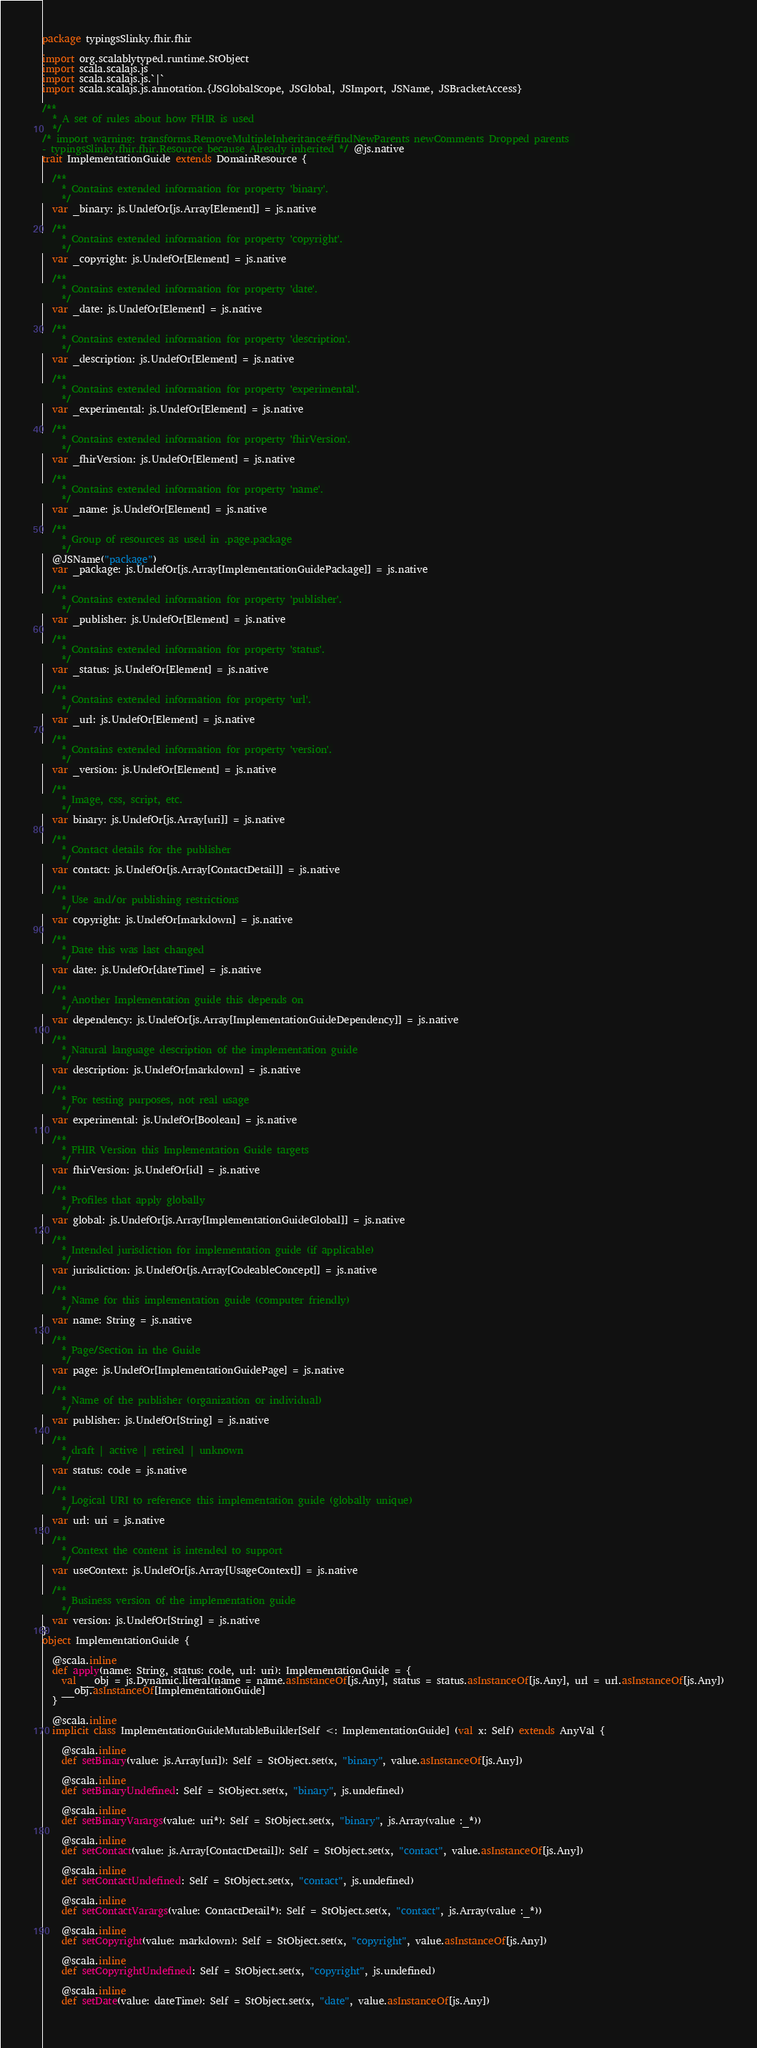<code> <loc_0><loc_0><loc_500><loc_500><_Scala_>package typingsSlinky.fhir.fhir

import org.scalablytyped.runtime.StObject
import scala.scalajs.js
import scala.scalajs.js.`|`
import scala.scalajs.js.annotation.{JSGlobalScope, JSGlobal, JSImport, JSName, JSBracketAccess}

/**
  * A set of rules about how FHIR is used
  */
/* import warning: transforms.RemoveMultipleInheritance#findNewParents newComments Dropped parents 
- typingsSlinky.fhir.fhir.Resource because Already inherited */ @js.native
trait ImplementationGuide extends DomainResource {
  
  /**
    * Contains extended information for property 'binary'.
    */
  var _binary: js.UndefOr[js.Array[Element]] = js.native
  
  /**
    * Contains extended information for property 'copyright'.
    */
  var _copyright: js.UndefOr[Element] = js.native
  
  /**
    * Contains extended information for property 'date'.
    */
  var _date: js.UndefOr[Element] = js.native
  
  /**
    * Contains extended information for property 'description'.
    */
  var _description: js.UndefOr[Element] = js.native
  
  /**
    * Contains extended information for property 'experimental'.
    */
  var _experimental: js.UndefOr[Element] = js.native
  
  /**
    * Contains extended information for property 'fhirVersion'.
    */
  var _fhirVersion: js.UndefOr[Element] = js.native
  
  /**
    * Contains extended information for property 'name'.
    */
  var _name: js.UndefOr[Element] = js.native
  
  /**
    * Group of resources as used in .page.package
    */
  @JSName("package")
  var _package: js.UndefOr[js.Array[ImplementationGuidePackage]] = js.native
  
  /**
    * Contains extended information for property 'publisher'.
    */
  var _publisher: js.UndefOr[Element] = js.native
  
  /**
    * Contains extended information for property 'status'.
    */
  var _status: js.UndefOr[Element] = js.native
  
  /**
    * Contains extended information for property 'url'.
    */
  var _url: js.UndefOr[Element] = js.native
  
  /**
    * Contains extended information for property 'version'.
    */
  var _version: js.UndefOr[Element] = js.native
  
  /**
    * Image, css, script, etc.
    */
  var binary: js.UndefOr[js.Array[uri]] = js.native
  
  /**
    * Contact details for the publisher
    */
  var contact: js.UndefOr[js.Array[ContactDetail]] = js.native
  
  /**
    * Use and/or publishing restrictions
    */
  var copyright: js.UndefOr[markdown] = js.native
  
  /**
    * Date this was last changed
    */
  var date: js.UndefOr[dateTime] = js.native
  
  /**
    * Another Implementation guide this depends on
    */
  var dependency: js.UndefOr[js.Array[ImplementationGuideDependency]] = js.native
  
  /**
    * Natural language description of the implementation guide
    */
  var description: js.UndefOr[markdown] = js.native
  
  /**
    * For testing purposes, not real usage
    */
  var experimental: js.UndefOr[Boolean] = js.native
  
  /**
    * FHIR Version this Implementation Guide targets
    */
  var fhirVersion: js.UndefOr[id] = js.native
  
  /**
    * Profiles that apply globally
    */
  var global: js.UndefOr[js.Array[ImplementationGuideGlobal]] = js.native
  
  /**
    * Intended jurisdiction for implementation guide (if applicable)
    */
  var jurisdiction: js.UndefOr[js.Array[CodeableConcept]] = js.native
  
  /**
    * Name for this implementation guide (computer friendly)
    */
  var name: String = js.native
  
  /**
    * Page/Section in the Guide
    */
  var page: js.UndefOr[ImplementationGuidePage] = js.native
  
  /**
    * Name of the publisher (organization or individual)
    */
  var publisher: js.UndefOr[String] = js.native
  
  /**
    * draft | active | retired | unknown
    */
  var status: code = js.native
  
  /**
    * Logical URI to reference this implementation guide (globally unique)
    */
  var url: uri = js.native
  
  /**
    * Context the content is intended to support
    */
  var useContext: js.UndefOr[js.Array[UsageContext]] = js.native
  
  /**
    * Business version of the implementation guide
    */
  var version: js.UndefOr[String] = js.native
}
object ImplementationGuide {
  
  @scala.inline
  def apply(name: String, status: code, url: uri): ImplementationGuide = {
    val __obj = js.Dynamic.literal(name = name.asInstanceOf[js.Any], status = status.asInstanceOf[js.Any], url = url.asInstanceOf[js.Any])
    __obj.asInstanceOf[ImplementationGuide]
  }
  
  @scala.inline
  implicit class ImplementationGuideMutableBuilder[Self <: ImplementationGuide] (val x: Self) extends AnyVal {
    
    @scala.inline
    def setBinary(value: js.Array[uri]): Self = StObject.set(x, "binary", value.asInstanceOf[js.Any])
    
    @scala.inline
    def setBinaryUndefined: Self = StObject.set(x, "binary", js.undefined)
    
    @scala.inline
    def setBinaryVarargs(value: uri*): Self = StObject.set(x, "binary", js.Array(value :_*))
    
    @scala.inline
    def setContact(value: js.Array[ContactDetail]): Self = StObject.set(x, "contact", value.asInstanceOf[js.Any])
    
    @scala.inline
    def setContactUndefined: Self = StObject.set(x, "contact", js.undefined)
    
    @scala.inline
    def setContactVarargs(value: ContactDetail*): Self = StObject.set(x, "contact", js.Array(value :_*))
    
    @scala.inline
    def setCopyright(value: markdown): Self = StObject.set(x, "copyright", value.asInstanceOf[js.Any])
    
    @scala.inline
    def setCopyrightUndefined: Self = StObject.set(x, "copyright", js.undefined)
    
    @scala.inline
    def setDate(value: dateTime): Self = StObject.set(x, "date", value.asInstanceOf[js.Any])
    </code> 